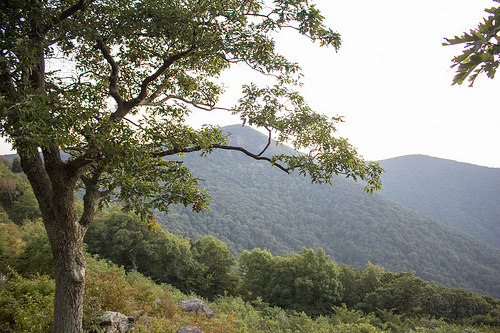<image>
Can you confirm if the tree is behind the mountain? No. The tree is not behind the mountain. From this viewpoint, the tree appears to be positioned elsewhere in the scene. 